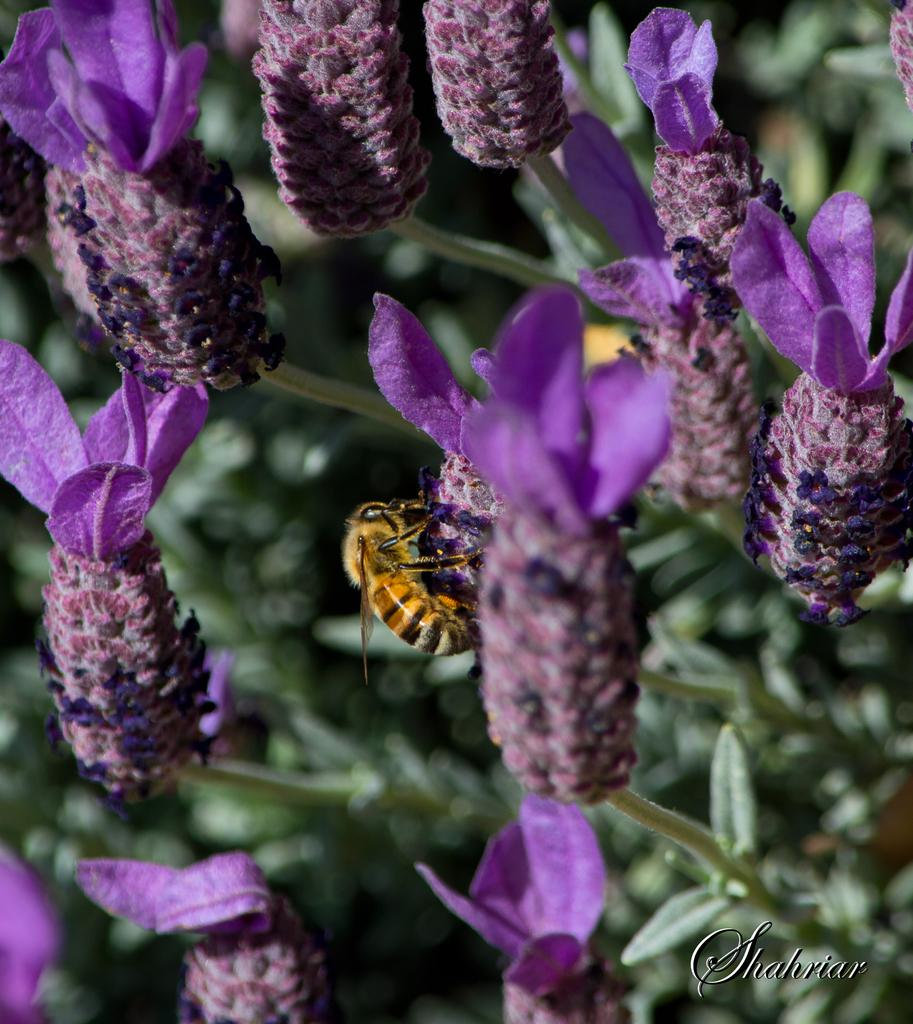What type of plant life is present in the image? There are flowers with stems and leaves in the image. Are there any living organisms interacting with the flowers? Yes, there is an insect on one of the flowers. What can be found in the right bottom corner of the image? There is text in the right bottom corner of the image. How would you describe the background of the image? The background of the image is blurry. What type of meat is being prepared on the grill in the image? There is no grill or meat present in the image; it features flowers, an insect, text, and a blurry background. 